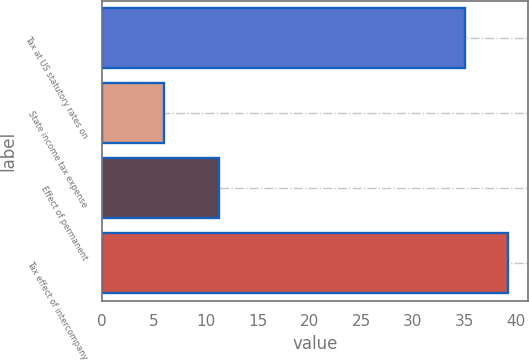<chart> <loc_0><loc_0><loc_500><loc_500><bar_chart><fcel>Tax at US statutory rates on<fcel>State income tax expense<fcel>Effect of permanent<fcel>Tax effect of intercompany<nl><fcel>35<fcel>6<fcel>11.3<fcel>39.2<nl></chart> 